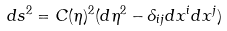Convert formula to latex. <formula><loc_0><loc_0><loc_500><loc_500>d s ^ { 2 } = C ( \eta ) ^ { 2 } ( d \eta ^ { 2 } - \delta _ { i j } d x ^ { i } d x ^ { j } )</formula> 